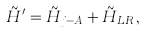Convert formula to latex. <formula><loc_0><loc_0><loc_500><loc_500>\tilde { H } ^ { \prime } = \tilde { H } _ { j - A } + \tilde { H } _ { L R } \, ,</formula> 